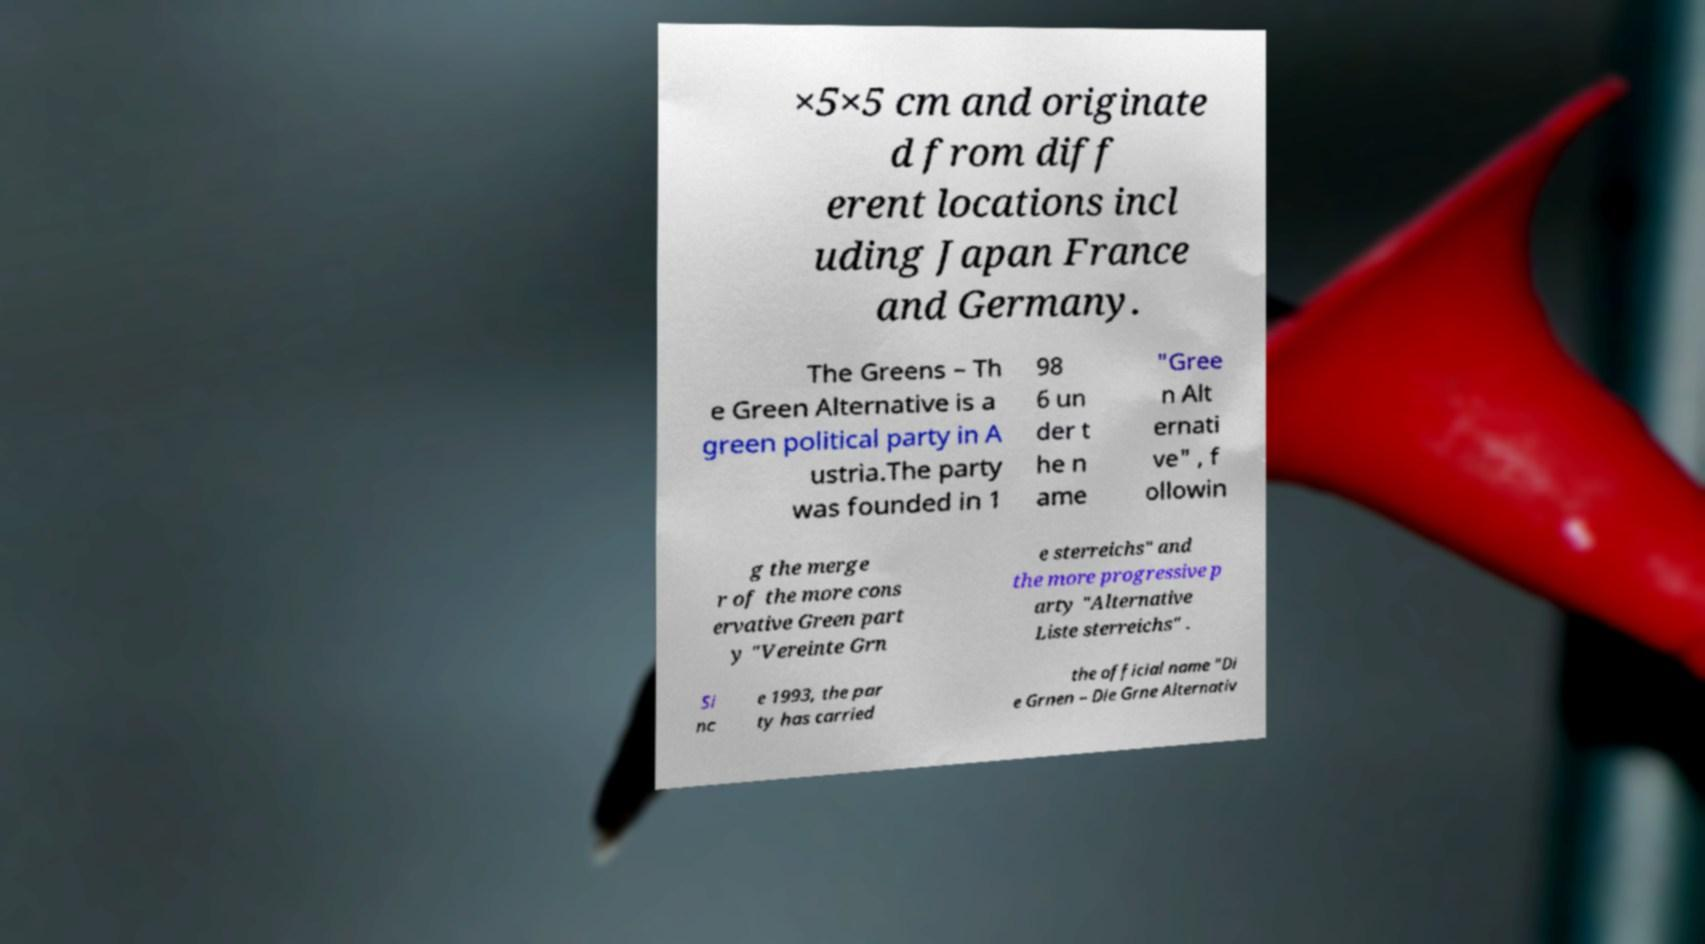Please read and relay the text visible in this image. What does it say? ×5×5 cm and originate d from diff erent locations incl uding Japan France and Germany. The Greens – Th e Green Alternative is a green political party in A ustria.The party was founded in 1 98 6 un der t he n ame "Gree n Alt ernati ve" , f ollowin g the merge r of the more cons ervative Green part y "Vereinte Grn e sterreichs" and the more progressive p arty "Alternative Liste sterreichs" . Si nc e 1993, the par ty has carried the official name "Di e Grnen – Die Grne Alternativ 